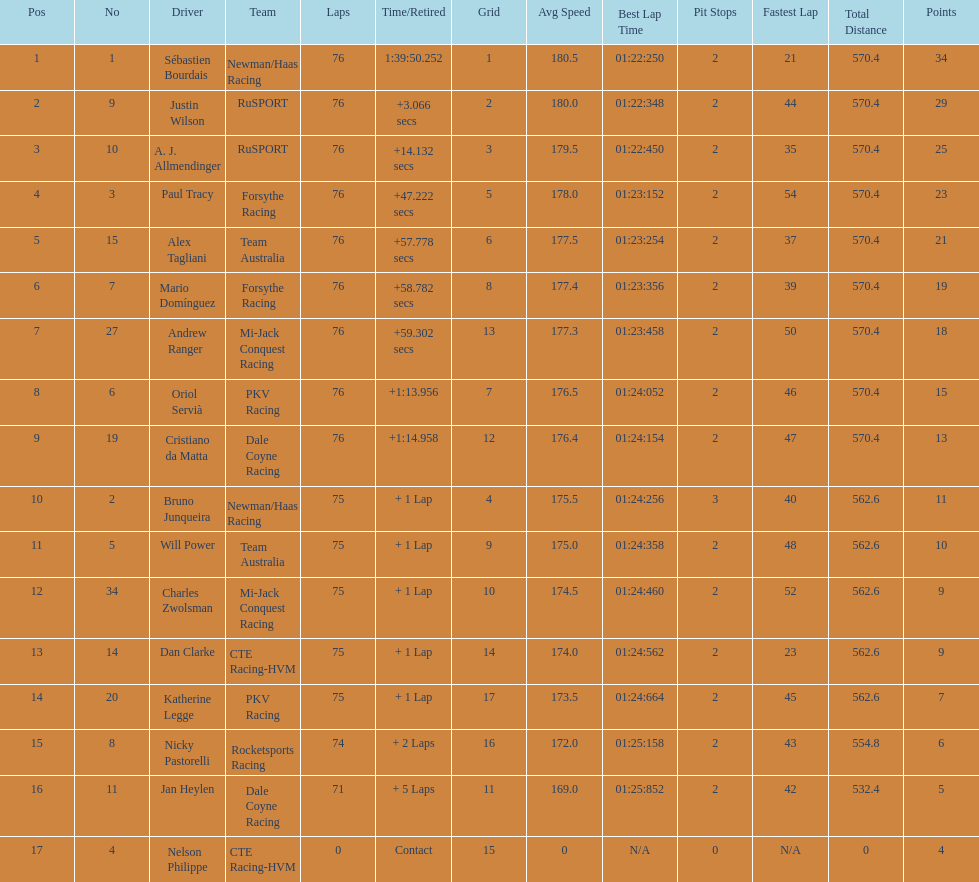Charles zwolsman acquired the same number of points as who? Dan Clarke. 